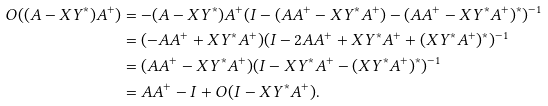<formula> <loc_0><loc_0><loc_500><loc_500>O ( ( A - X Y ^ { * } ) A ^ { + } ) & = - ( A - X Y ^ { * } ) A ^ { + } ( I - ( A A ^ { + } - X Y ^ { * } A ^ { + } ) - ( A A ^ { + } - X Y ^ { * } A ^ { + } ) ^ { * } ) ^ { - 1 } \\ & = ( - A A ^ { + } + X Y ^ { * } A ^ { + } ) ( I - 2 A A ^ { + } + X Y ^ { * } A ^ { + } + ( X Y ^ { * } A ^ { + } ) ^ { * } ) ^ { - 1 } \\ & = ( A A ^ { + } - X Y ^ { * } A ^ { + } ) ( I - X Y ^ { * } A ^ { + } - ( X Y ^ { * } A ^ { + } ) ^ { * } ) ^ { - 1 } \\ & = A A ^ { + } - I + O ( I - X Y ^ { * } A ^ { + } ) .</formula> 